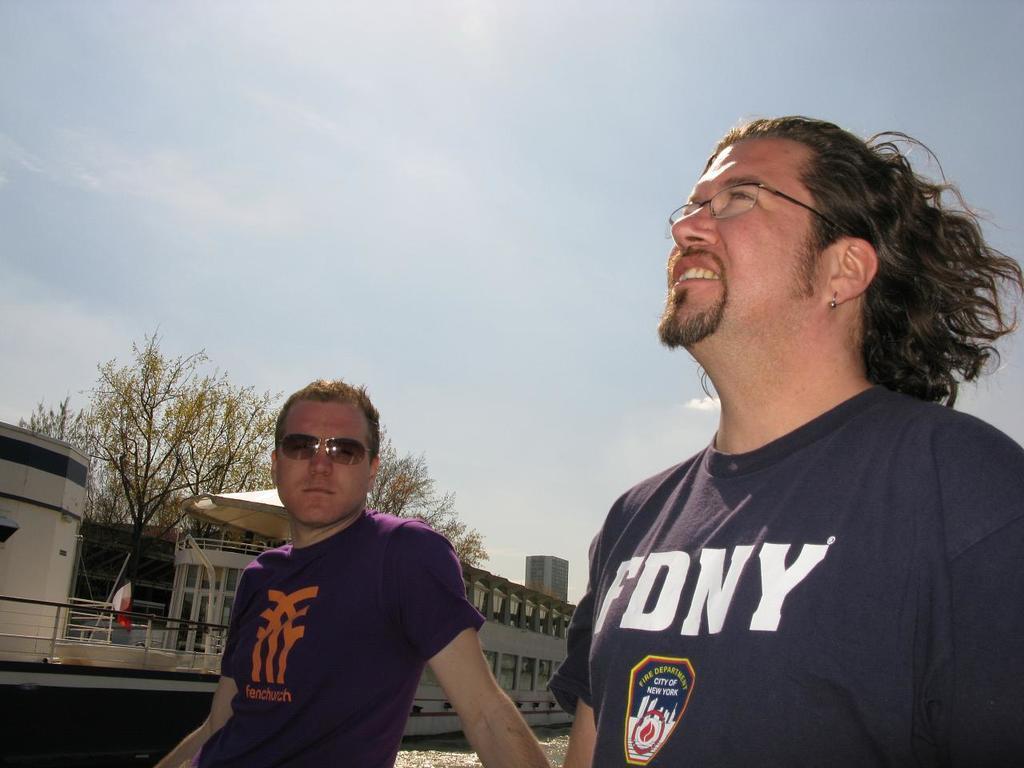Describe this image in one or two sentences. In this image in the center there are two persons who are standing, and in the background there is river and some boats and buildings and trees. At the top of the mage there is sky. 